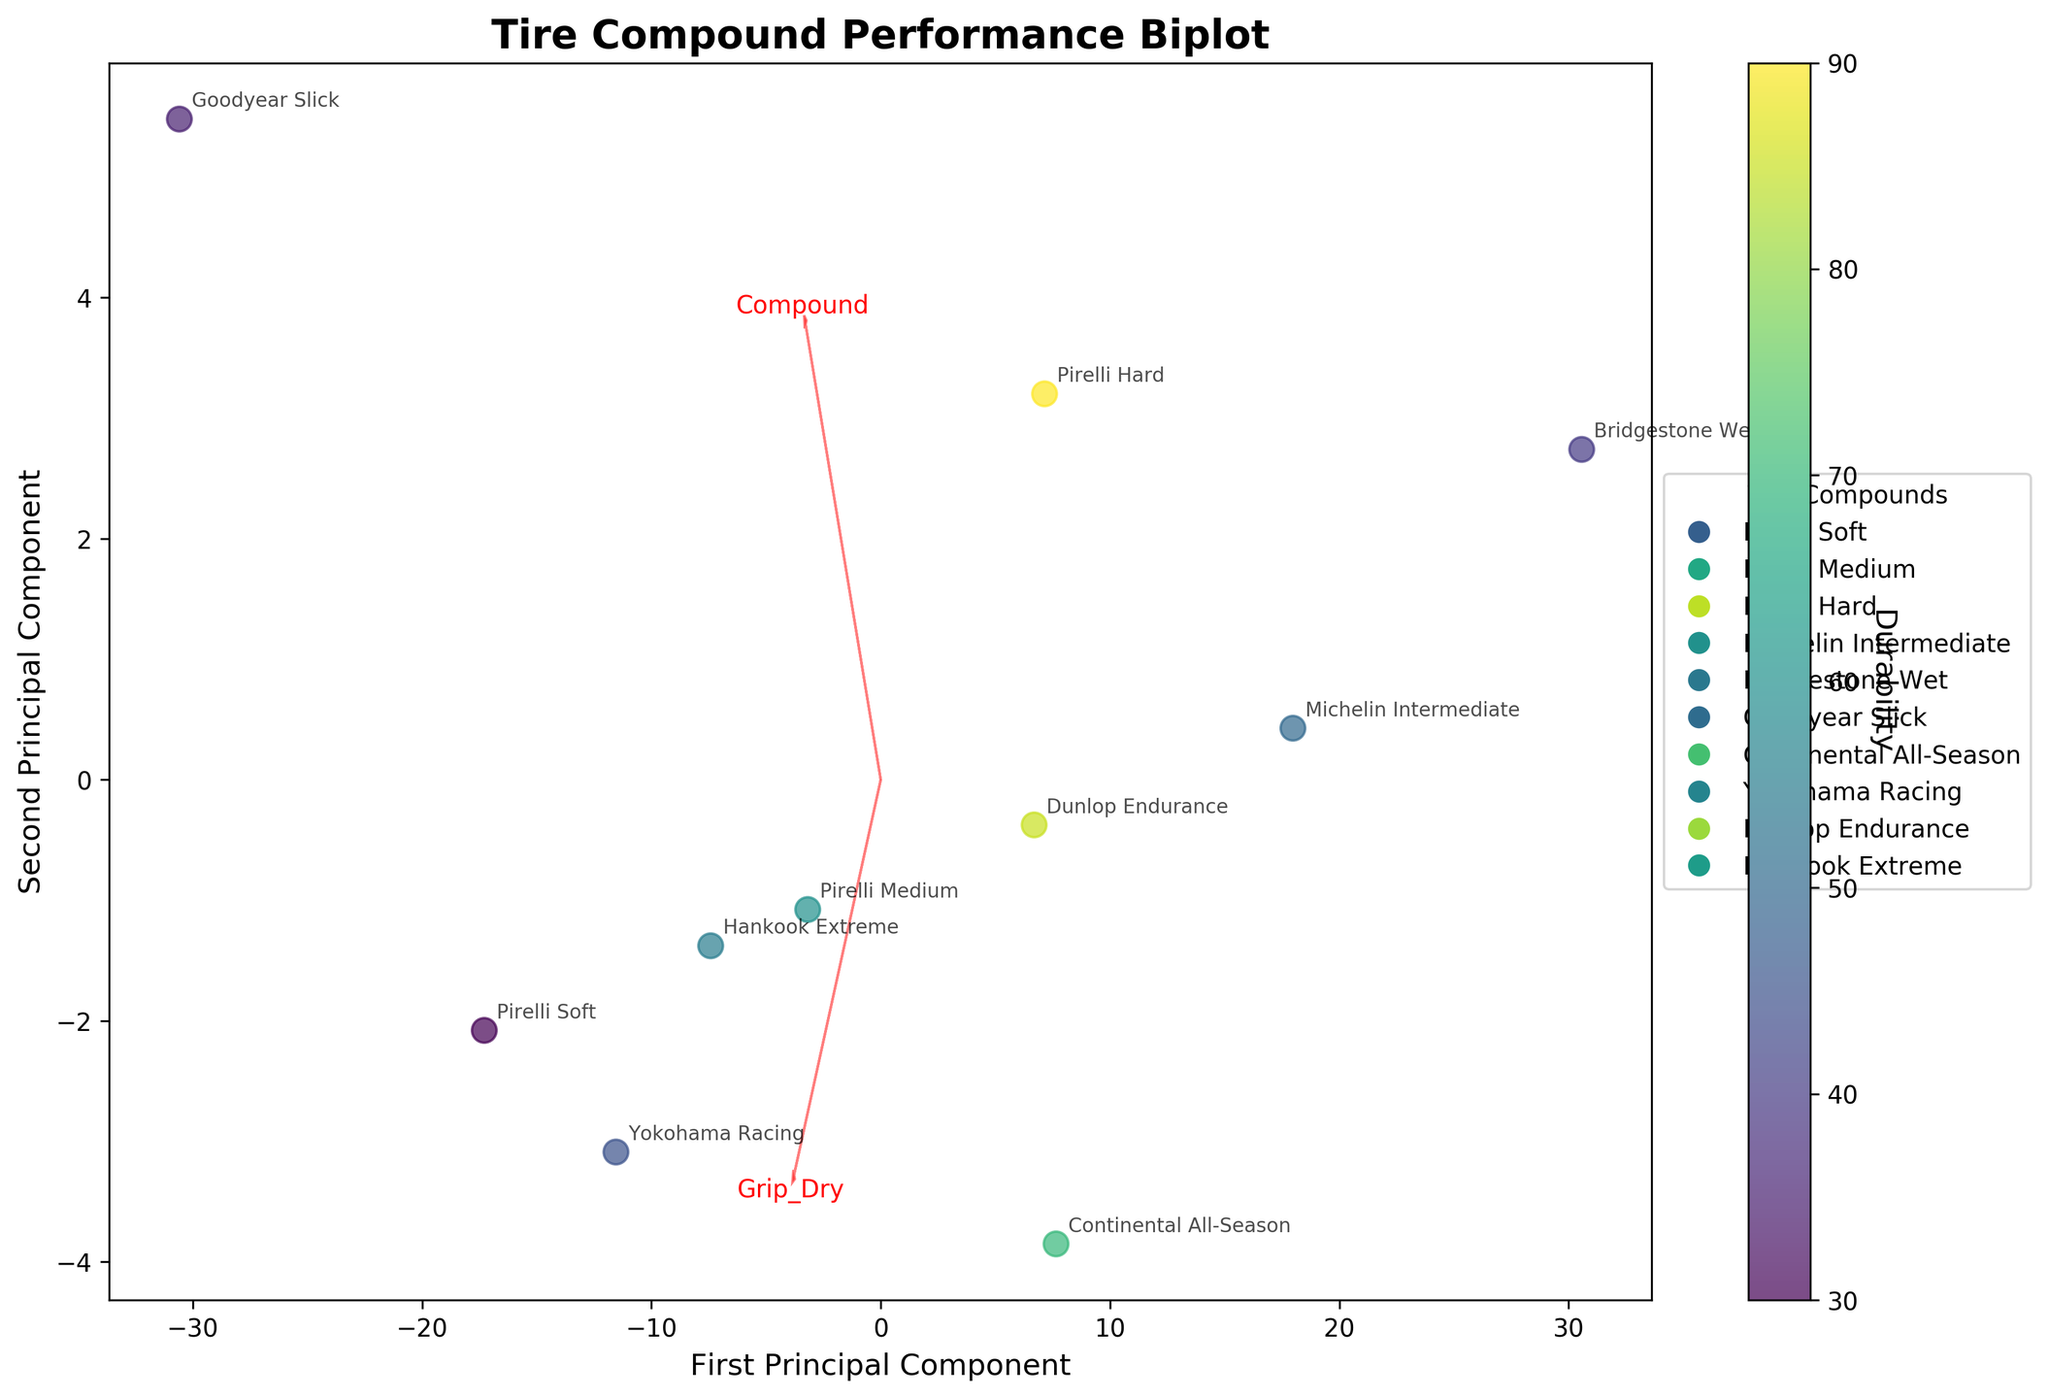What's the title of the biplot? Look at the top of the biplot for the title of the figure.
Answer: Tire Compound Performance Biplot How many principal components are displayed on the axes? The x-axis and y-axis of the biplot represent the first and second principal components, respectively.
Answer: 2 Which tire compound shows the highest durability based on color intensity? Observe the color of each data point in the biplot, where warmer colors (yellow) indicate higher durability.
Answer: Pirelli Hard What are the coordinates of the Michelin Intermediate tire compound in the principal component space? Locate the Michelin Intermediate data point on the biplot and read off its coordinates on the first and second principal components.
Answer: Approximately (-10, 10) Which variable vector points more towards the direction of higher wet grip, 'Grip_Dry' or 'Grip_Wet'? Look at the direction of the variable vectors and compare which one is more aligned with the data points having higher wet grip values.
Answer: Grip_Wet Compare the dry grip levels of Goodyear Slick and Yokohama Racing compounds. Which one performs better? Check the position of Goodyear Slick and Yokohama Racing along the direction of the 'Grip_Dry' vector.
Answer: Goodyear Slick What range of durability values is represented in the biplot? Examine the color bar on the right side of the biplot to see the range of durability values.
Answer: 30 to 90 Is there an evident trade-off between grip in dry conditions and durability based on the plot? Analyze the spread of data points with respect to the 'Grip_Dry' vector and their corresponding durability (color intensity).
Answer: Yes Estimate the operating temperature for the tires that are clustered near the center of the principal component space. The tires near the center include Pirelli Medium and Dunlop Endurance. Check their operating temperatures in the provided data.
Answer: 100°C and 85°C Which tire compounds appear to be optimized for wet conditions as per the biplot? Identify the compounds located towards the positive end of the 'Grip_Wet' vector.
Answer: Michelin Intermediate and Bridgestone Wet 